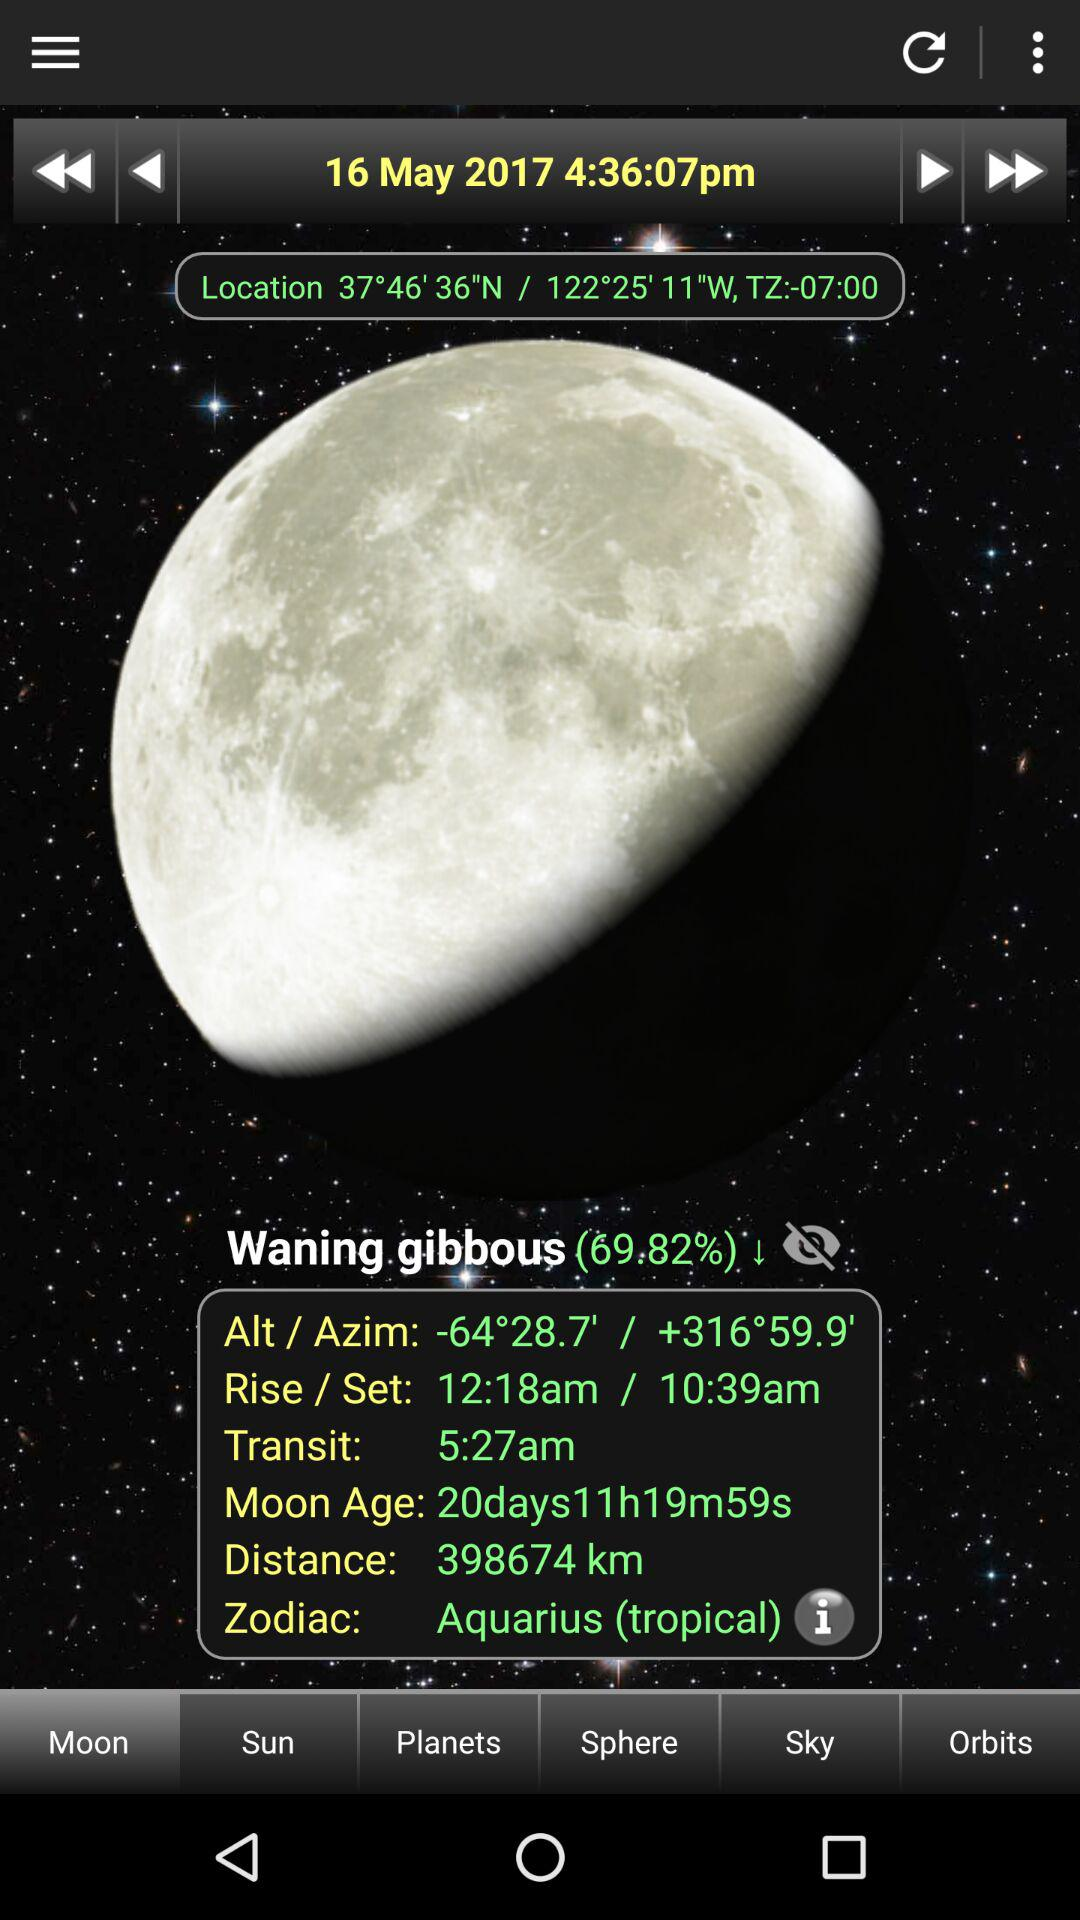What is the zodiac sign of the moon?
Answer the question using a single word or phrase. Aquarius 